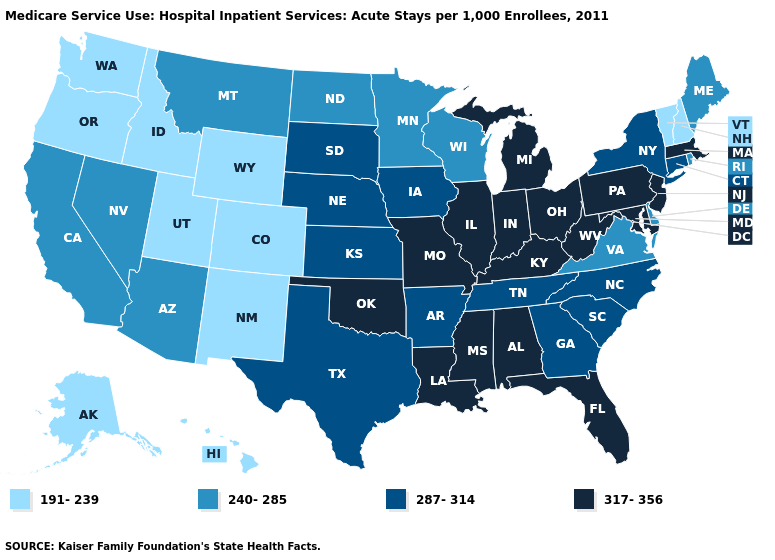Among the states that border Nevada , which have the highest value?
Give a very brief answer. Arizona, California. What is the value of Kentucky?
Write a very short answer. 317-356. Name the states that have a value in the range 240-285?
Write a very short answer. Arizona, California, Delaware, Maine, Minnesota, Montana, Nevada, North Dakota, Rhode Island, Virginia, Wisconsin. Is the legend a continuous bar?
Answer briefly. No. Is the legend a continuous bar?
Short answer required. No. Which states have the lowest value in the MidWest?
Answer briefly. Minnesota, North Dakota, Wisconsin. Name the states that have a value in the range 317-356?
Give a very brief answer. Alabama, Florida, Illinois, Indiana, Kentucky, Louisiana, Maryland, Massachusetts, Michigan, Mississippi, Missouri, New Jersey, Ohio, Oklahoma, Pennsylvania, West Virginia. What is the value of North Dakota?
Write a very short answer. 240-285. Does Maryland have the highest value in the USA?
Give a very brief answer. Yes. What is the value of Massachusetts?
Quick response, please. 317-356. Among the states that border West Virginia , which have the lowest value?
Answer briefly. Virginia. Which states have the lowest value in the Northeast?
Concise answer only. New Hampshire, Vermont. What is the lowest value in the USA?
Write a very short answer. 191-239. Name the states that have a value in the range 287-314?
Write a very short answer. Arkansas, Connecticut, Georgia, Iowa, Kansas, Nebraska, New York, North Carolina, South Carolina, South Dakota, Tennessee, Texas. Which states hav the highest value in the South?
Write a very short answer. Alabama, Florida, Kentucky, Louisiana, Maryland, Mississippi, Oklahoma, West Virginia. 